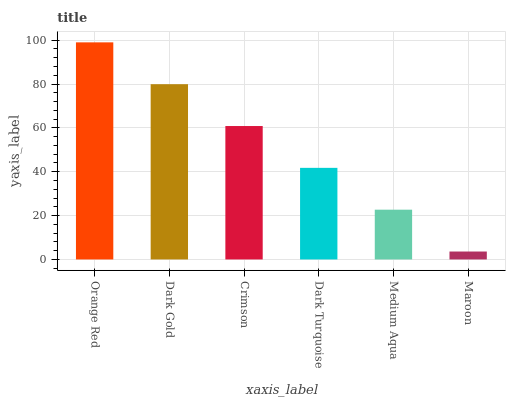Is Maroon the minimum?
Answer yes or no. Yes. Is Orange Red the maximum?
Answer yes or no. Yes. Is Dark Gold the minimum?
Answer yes or no. No. Is Dark Gold the maximum?
Answer yes or no. No. Is Orange Red greater than Dark Gold?
Answer yes or no. Yes. Is Dark Gold less than Orange Red?
Answer yes or no. Yes. Is Dark Gold greater than Orange Red?
Answer yes or no. No. Is Orange Red less than Dark Gold?
Answer yes or no. No. Is Crimson the high median?
Answer yes or no. Yes. Is Dark Turquoise the low median?
Answer yes or no. Yes. Is Dark Turquoise the high median?
Answer yes or no. No. Is Maroon the low median?
Answer yes or no. No. 